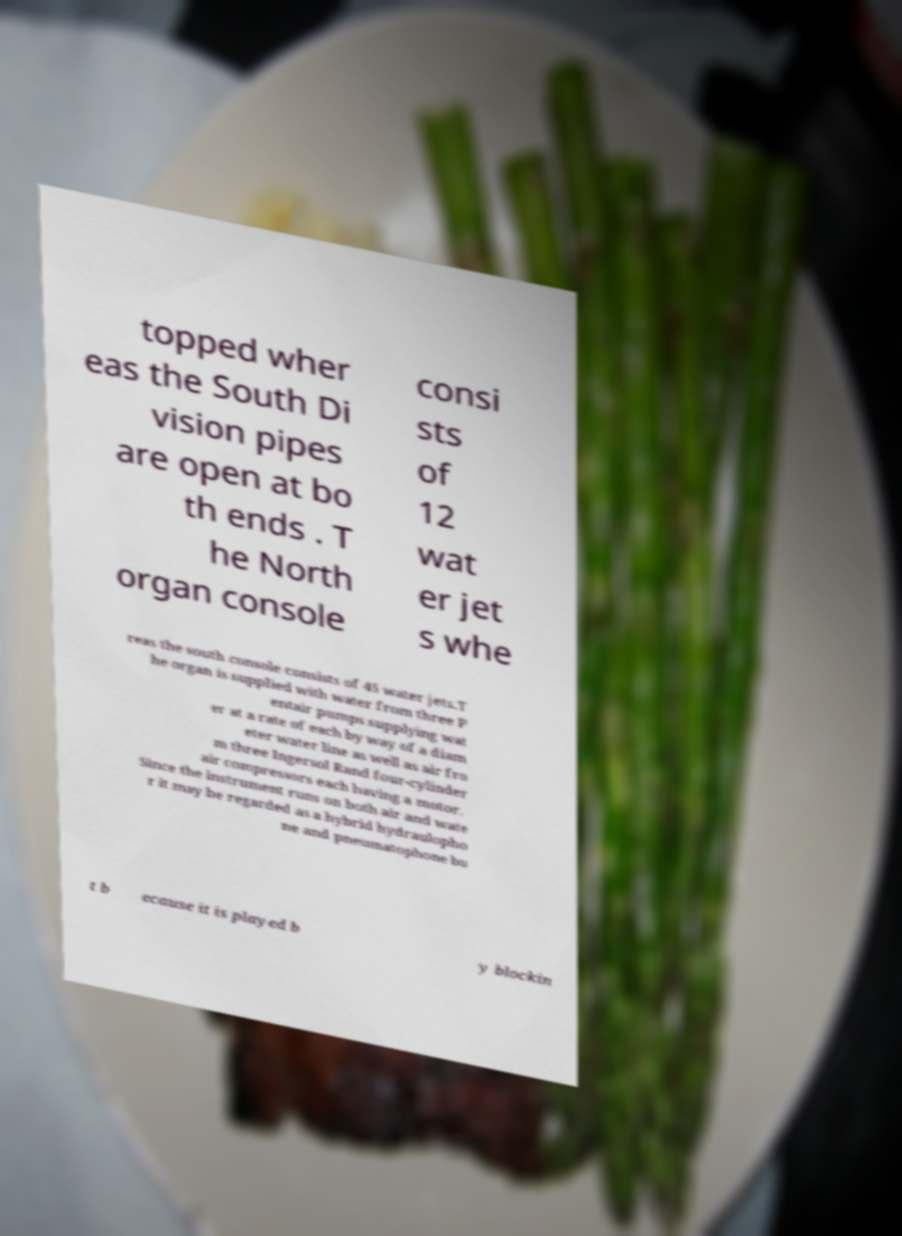Could you extract and type out the text from this image? topped wher eas the South Di vision pipes are open at bo th ends . T he North organ console consi sts of 12 wat er jet s whe reas the south console consists of 45 water jets.T he organ is supplied with water from three P entair pumps supplying wat er at a rate of each by way of a diam eter water line as well as air fro m three Ingersol Rand four-cylinder air compressors each having a motor. Since the instrument runs on both air and wate r it may be regarded as a hybrid hydraulopho ne and pneumatophone bu t b ecause it is played b y blockin 